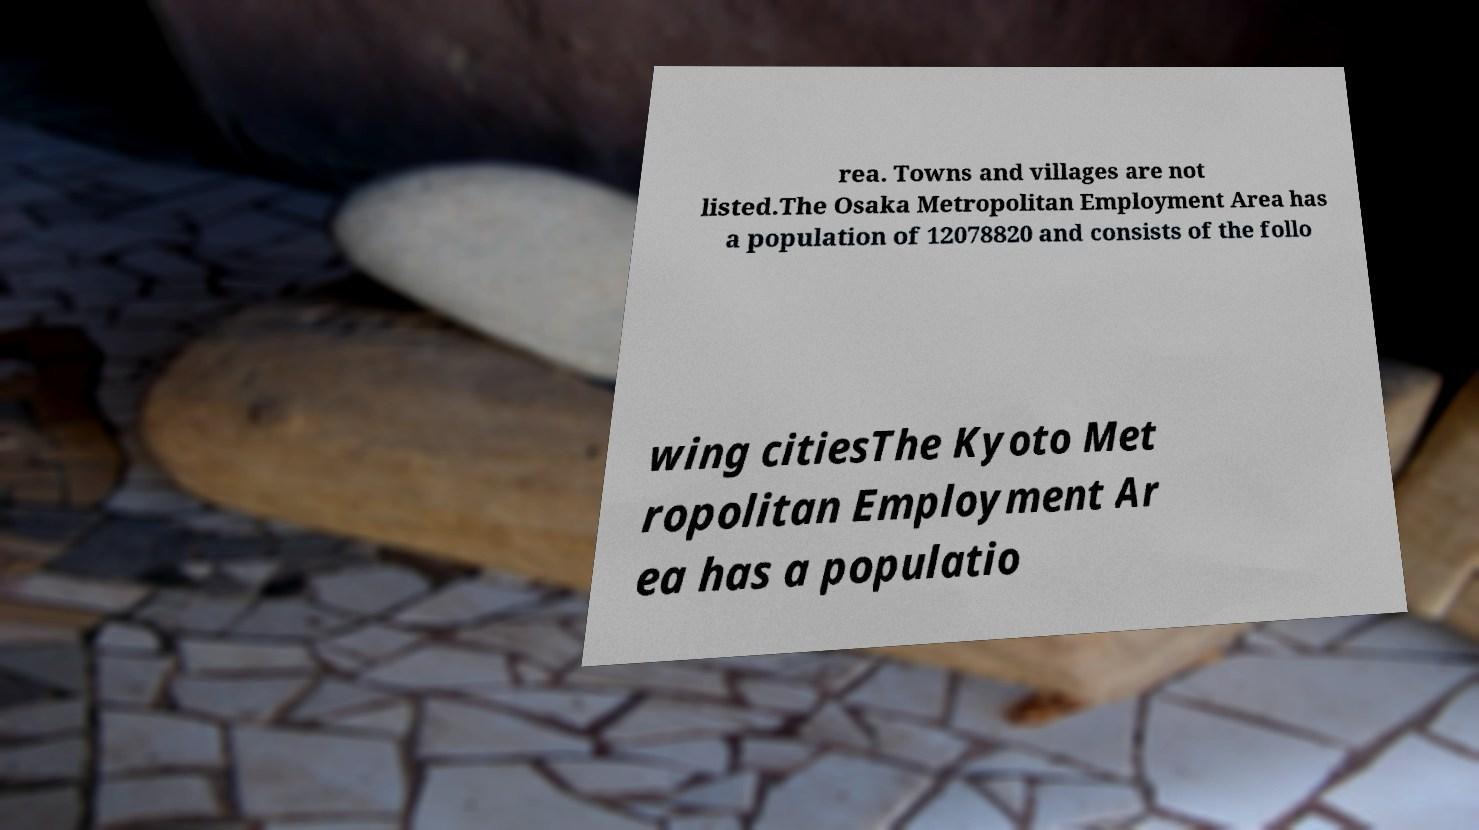There's text embedded in this image that I need extracted. Can you transcribe it verbatim? rea. Towns and villages are not listed.The Osaka Metropolitan Employment Area has a population of 12078820 and consists of the follo wing citiesThe Kyoto Met ropolitan Employment Ar ea has a populatio 